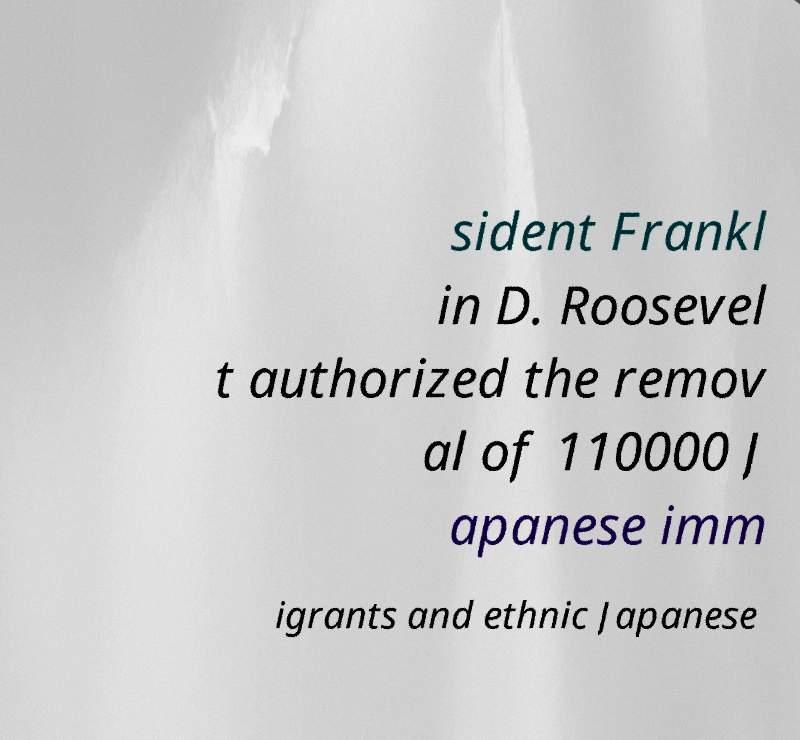Please read and relay the text visible in this image. What does it say? sident Frankl in D. Roosevel t authorized the remov al of 110000 J apanese imm igrants and ethnic Japanese 